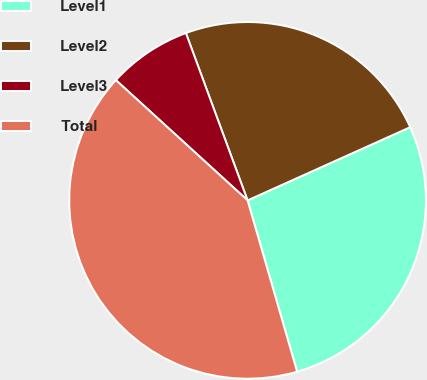<chart> <loc_0><loc_0><loc_500><loc_500><pie_chart><fcel>Level1<fcel>Level2<fcel>Level3<fcel>Total<nl><fcel>27.25%<fcel>23.89%<fcel>7.6%<fcel>41.26%<nl></chart> 